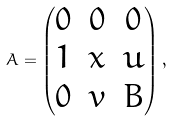<formula> <loc_0><loc_0><loc_500><loc_500>A = \begin{pmatrix} 0 & 0 & 0 \\ 1 & x & u \\ 0 & v & B \end{pmatrix} ,</formula> 